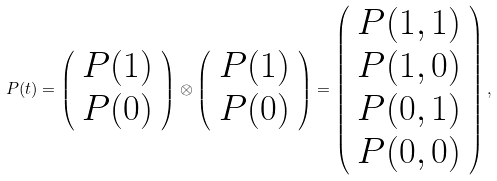<formula> <loc_0><loc_0><loc_500><loc_500>P ( t ) = \left ( \begin{array} { c } P ( 1 ) \\ P ( 0 ) \end{array} \right ) \otimes \left ( \begin{array} { c } P ( 1 ) \\ P ( 0 ) \end{array} \right ) = \left ( \begin{array} { c } P ( 1 , 1 ) \\ P ( 1 , 0 ) \\ P ( 0 , 1 ) \\ P ( 0 , 0 ) \end{array} \right ) ,</formula> 